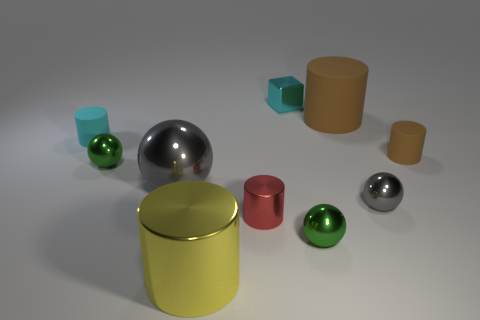What number of objects are small gray metal objects or matte things right of the big yellow shiny cylinder?
Provide a succinct answer. 3. Are there any green objects that have the same material as the red object?
Give a very brief answer. Yes. What number of small things are on the left side of the large brown cylinder and right of the tiny gray object?
Ensure brevity in your answer.  0. There is a green ball that is behind the red metal cylinder; what material is it?
Give a very brief answer. Metal. The red cylinder that is made of the same material as the large gray sphere is what size?
Ensure brevity in your answer.  Small. There is a small brown rubber object; are there any big yellow objects right of it?
Keep it short and to the point. No. What size is the red object that is the same shape as the cyan matte thing?
Ensure brevity in your answer.  Small. Is the color of the large shiny cylinder the same as the small block on the right side of the large gray thing?
Provide a short and direct response. No. Is the color of the big ball the same as the tiny shiny block?
Provide a short and direct response. No. Is the number of yellow metallic cylinders less than the number of things?
Make the answer very short. Yes. 